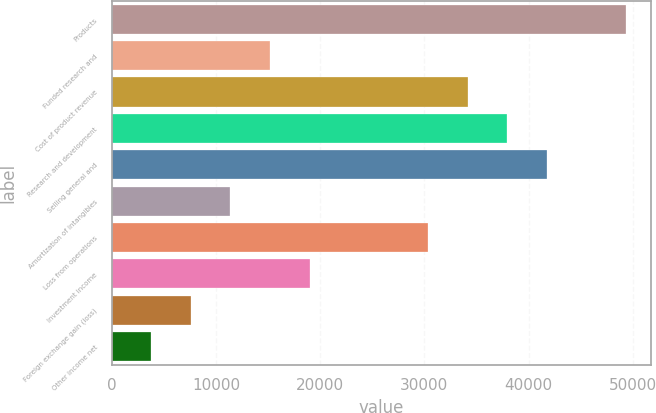Convert chart to OTSL. <chart><loc_0><loc_0><loc_500><loc_500><bar_chart><fcel>Products<fcel>Funded research and<fcel>Cost of product revenue<fcel>Research and development<fcel>Selling general and<fcel>Amortization of intangibles<fcel>Loss from operations<fcel>Investment income<fcel>Foreign exchange gain (loss)<fcel>Other income net<nl><fcel>49328.5<fcel>15178.1<fcel>34150.5<fcel>37945<fcel>41739.5<fcel>11383.6<fcel>30356<fcel>18972.6<fcel>7589.09<fcel>3794.6<nl></chart> 